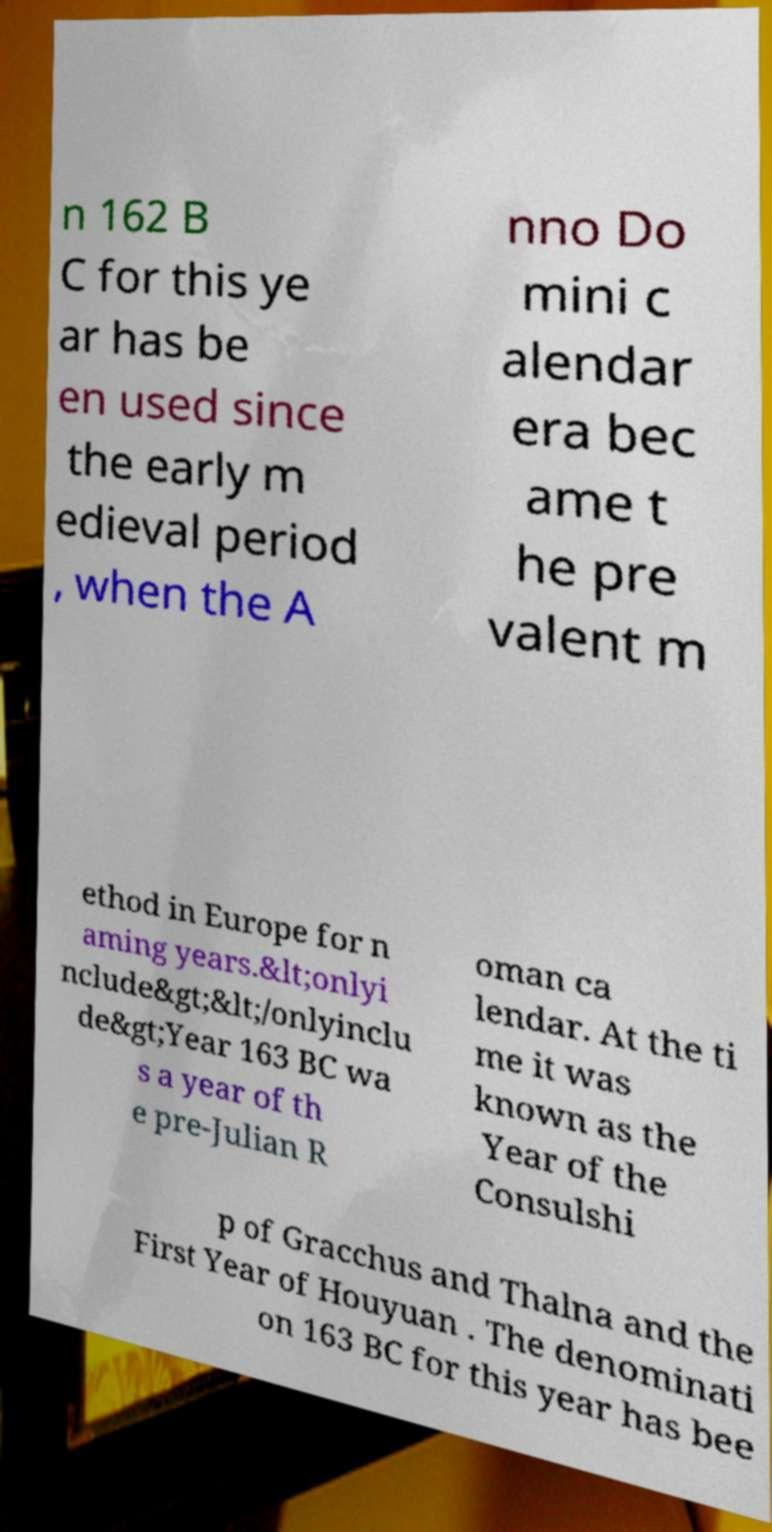What messages or text are displayed in this image? I need them in a readable, typed format. n 162 B C for this ye ar has be en used since the early m edieval period , when the A nno Do mini c alendar era bec ame t he pre valent m ethod in Europe for n aming years.&lt;onlyi nclude&gt;&lt;/onlyinclu de&gt;Year 163 BC wa s a year of th e pre-Julian R oman ca lendar. At the ti me it was known as the Year of the Consulshi p of Gracchus and Thalna and the First Year of Houyuan . The denominati on 163 BC for this year has bee 